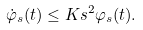Convert formula to latex. <formula><loc_0><loc_0><loc_500><loc_500>\dot { \varphi } _ { s } ( t ) \leq K s ^ { 2 } \varphi _ { s } ( t ) .</formula> 